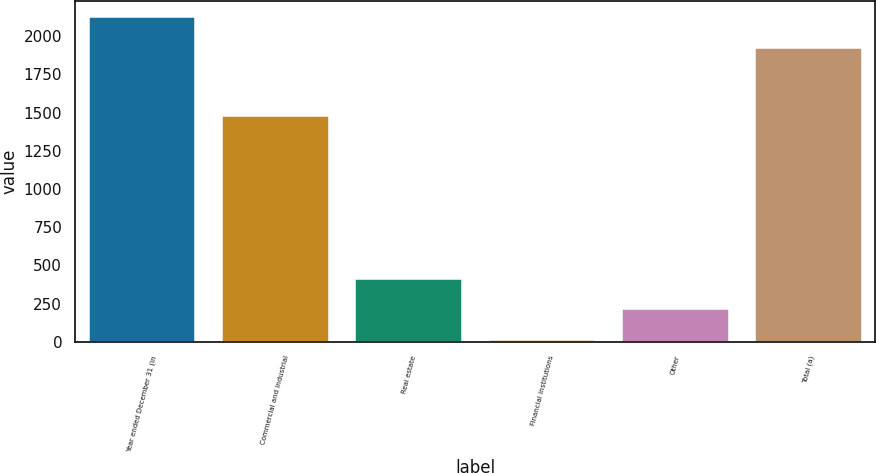Convert chart. <chart><loc_0><loc_0><loc_500><loc_500><bar_chart><fcel>Year ended December 31 (in<fcel>Commercial and industrial<fcel>Real estate<fcel>Financial institutions<fcel>Other<fcel>Total (a)<nl><fcel>2123.3<fcel>1480<fcel>413.6<fcel>13<fcel>213.3<fcel>1923<nl></chart> 